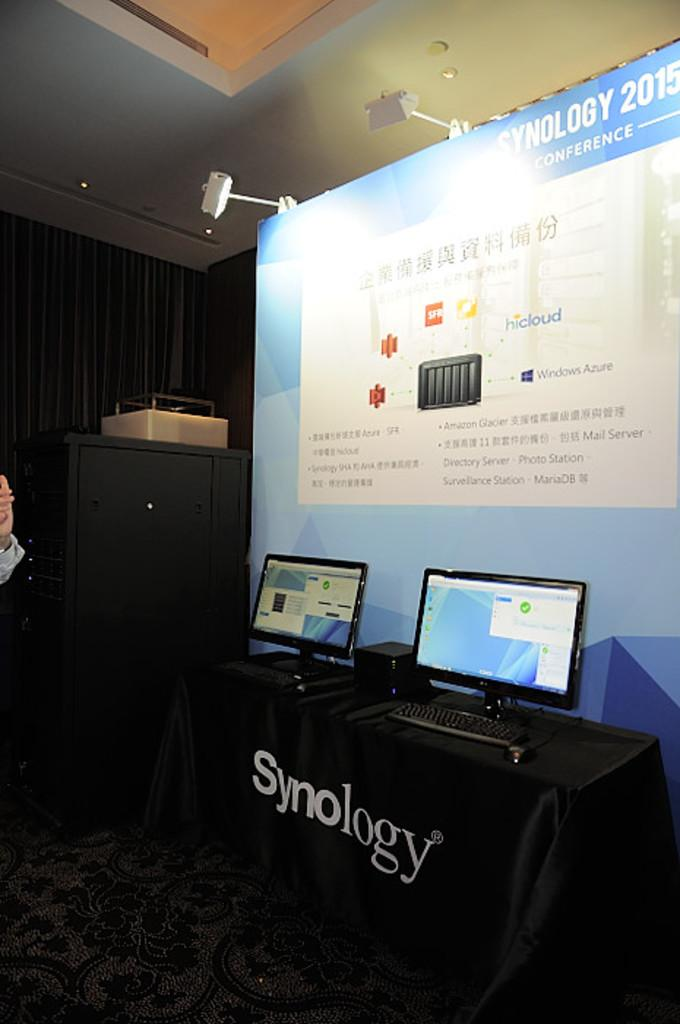<image>
Provide a brief description of the given image. A Synology set up with two computers and a backdrop. 